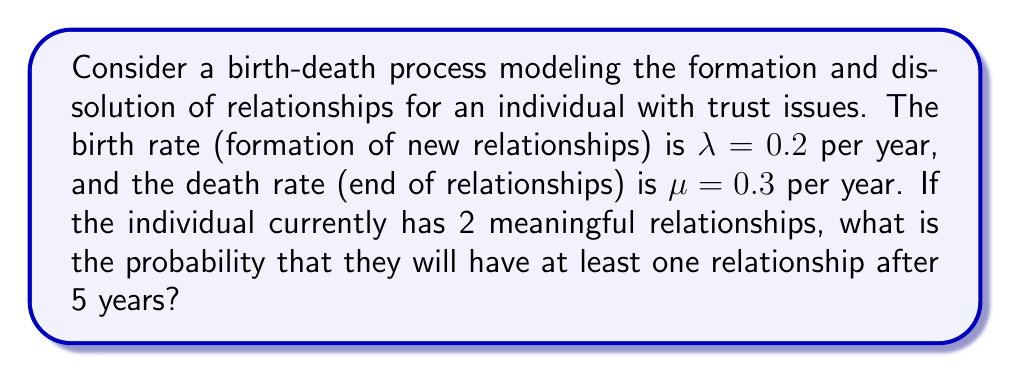Teach me how to tackle this problem. To solve this problem, we'll use the continuous-time Markov chain model for birth-death processes:

1. First, calculate the probability of transitioning from 2 to 0 relationships in 5 years:
   Let $P_{2,0}(t)$ be the probability of going from 2 to 0 relationships in time $t$.
   
   $$P_{2,0}(t) = e^{-(\lambda+\mu)t} \sum_{k=0}^{1} \frac{(\lambda t)^k (\mu t)^{2-k}}{k!(2-k)!}$$

2. Substitute the given values:
   $\lambda = 0.2$, $\mu = 0.3$, $t = 5$

   $$P_{2,0}(5) = e^{-(0.2+0.3)5} \left(\frac{(0.3 \cdot 5)^2}{2!} + \frac{(0.2 \cdot 5)(0.3 \cdot 5)}{1!1!}\right)$$

3. Calculate:
   $$P_{2,0}(5) = e^{-2.5} (1.125 + 0.75) = 0.0821 \cdot 1.875 = 0.1539$$

4. The probability of having at least one relationship after 5 years is the complement of this probability:

   $$P(\text{at least one relationship}) = 1 - P_{2,0}(5) = 1 - 0.1539 = 0.8461$$

5. Convert to percentage:
   $0.8461 \cdot 100\% = 84.61\%$
Answer: 84.61% 